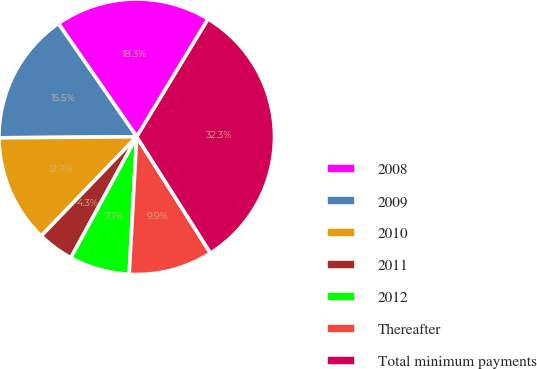Convert chart to OTSL. <chart><loc_0><loc_0><loc_500><loc_500><pie_chart><fcel>2008<fcel>2009<fcel>2010<fcel>2011<fcel>2012<fcel>Thereafter<fcel>Total minimum payments<nl><fcel>18.3%<fcel>15.49%<fcel>12.68%<fcel>4.26%<fcel>7.06%<fcel>9.87%<fcel>32.34%<nl></chart> 